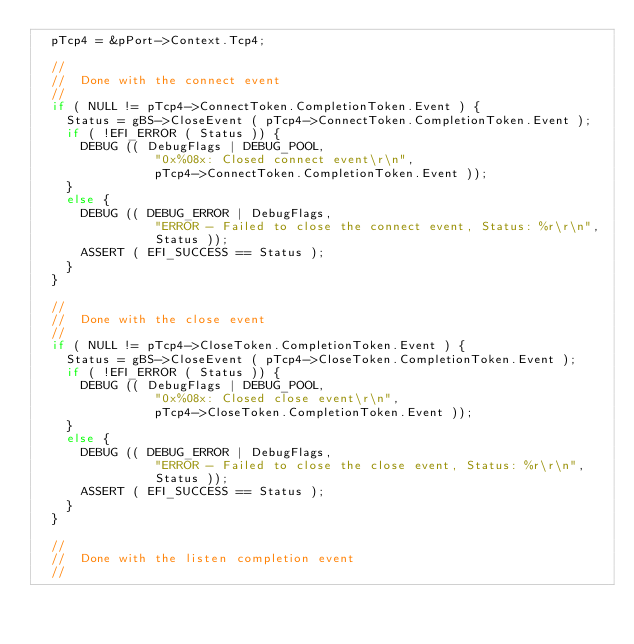<code> <loc_0><loc_0><loc_500><loc_500><_C_>  pTcp4 = &pPort->Context.Tcp4;

  //
  //  Done with the connect event
  //
  if ( NULL != pTcp4->ConnectToken.CompletionToken.Event ) {
    Status = gBS->CloseEvent ( pTcp4->ConnectToken.CompletionToken.Event );
    if ( !EFI_ERROR ( Status )) {
      DEBUG (( DebugFlags | DEBUG_POOL,
                "0x%08x: Closed connect event\r\n",
                pTcp4->ConnectToken.CompletionToken.Event ));
    }
    else {
      DEBUG (( DEBUG_ERROR | DebugFlags,
                "ERROR - Failed to close the connect event, Status: %r\r\n",
                Status ));
      ASSERT ( EFI_SUCCESS == Status );
    }
  }

  //
  //  Done with the close event
  //
  if ( NULL != pTcp4->CloseToken.CompletionToken.Event ) {
    Status = gBS->CloseEvent ( pTcp4->CloseToken.CompletionToken.Event );
    if ( !EFI_ERROR ( Status )) {
      DEBUG (( DebugFlags | DEBUG_POOL,
                "0x%08x: Closed close event\r\n",
                pTcp4->CloseToken.CompletionToken.Event ));
    }
    else {
      DEBUG (( DEBUG_ERROR | DebugFlags,
                "ERROR - Failed to close the close event, Status: %r\r\n",
                Status ));
      ASSERT ( EFI_SUCCESS == Status );
    }
  }

  //
  //  Done with the listen completion event
  //</code> 